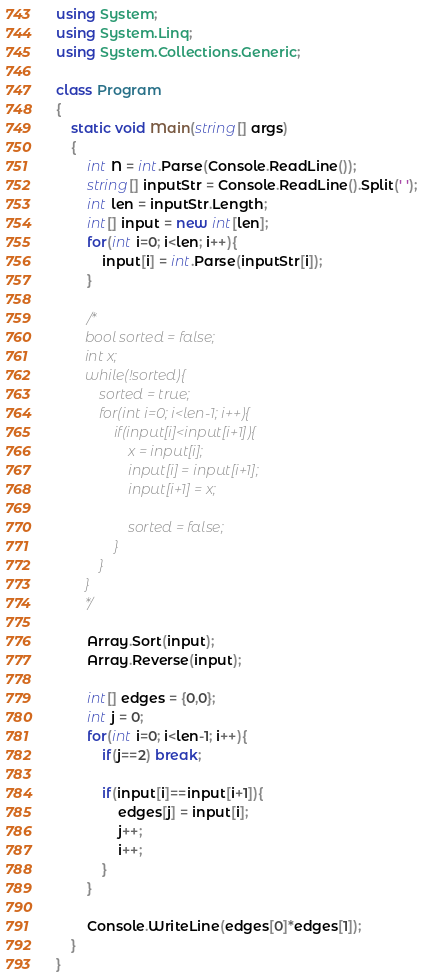<code> <loc_0><loc_0><loc_500><loc_500><_C#_>using System;
using System.Linq;
using System.Collections.Generic;

class Program
{
    static void Main(string[] args)
    {
        int N = int.Parse(Console.ReadLine());
        string[] inputStr = Console.ReadLine().Split(' ');
        int len = inputStr.Length;
        int[] input = new int[len];
        for(int i=0; i<len; i++){
            input[i] = int.Parse(inputStr[i]);
        }

        /*
        bool sorted = false;
        int x;
        while(!sorted){
            sorted = true;
            for(int i=0; i<len-1; i++){
                if(input[i]<input[i+1]){
                    x = input[i];
                    input[i] = input[i+1];
                    input[i+1] = x;

                    sorted = false;
                }
            }
        }
        */

        Array.Sort(input);
        Array.Reverse(input);

        int[] edges = {0,0};
        int j = 0;
        for(int i=0; i<len-1; i++){
            if(j==2) break;

            if(input[i]==input[i+1]){
                edges[j] = input[i];
                j++;
                i++;
            }
        }

        Console.WriteLine(edges[0]*edges[1]);
    }
}</code> 